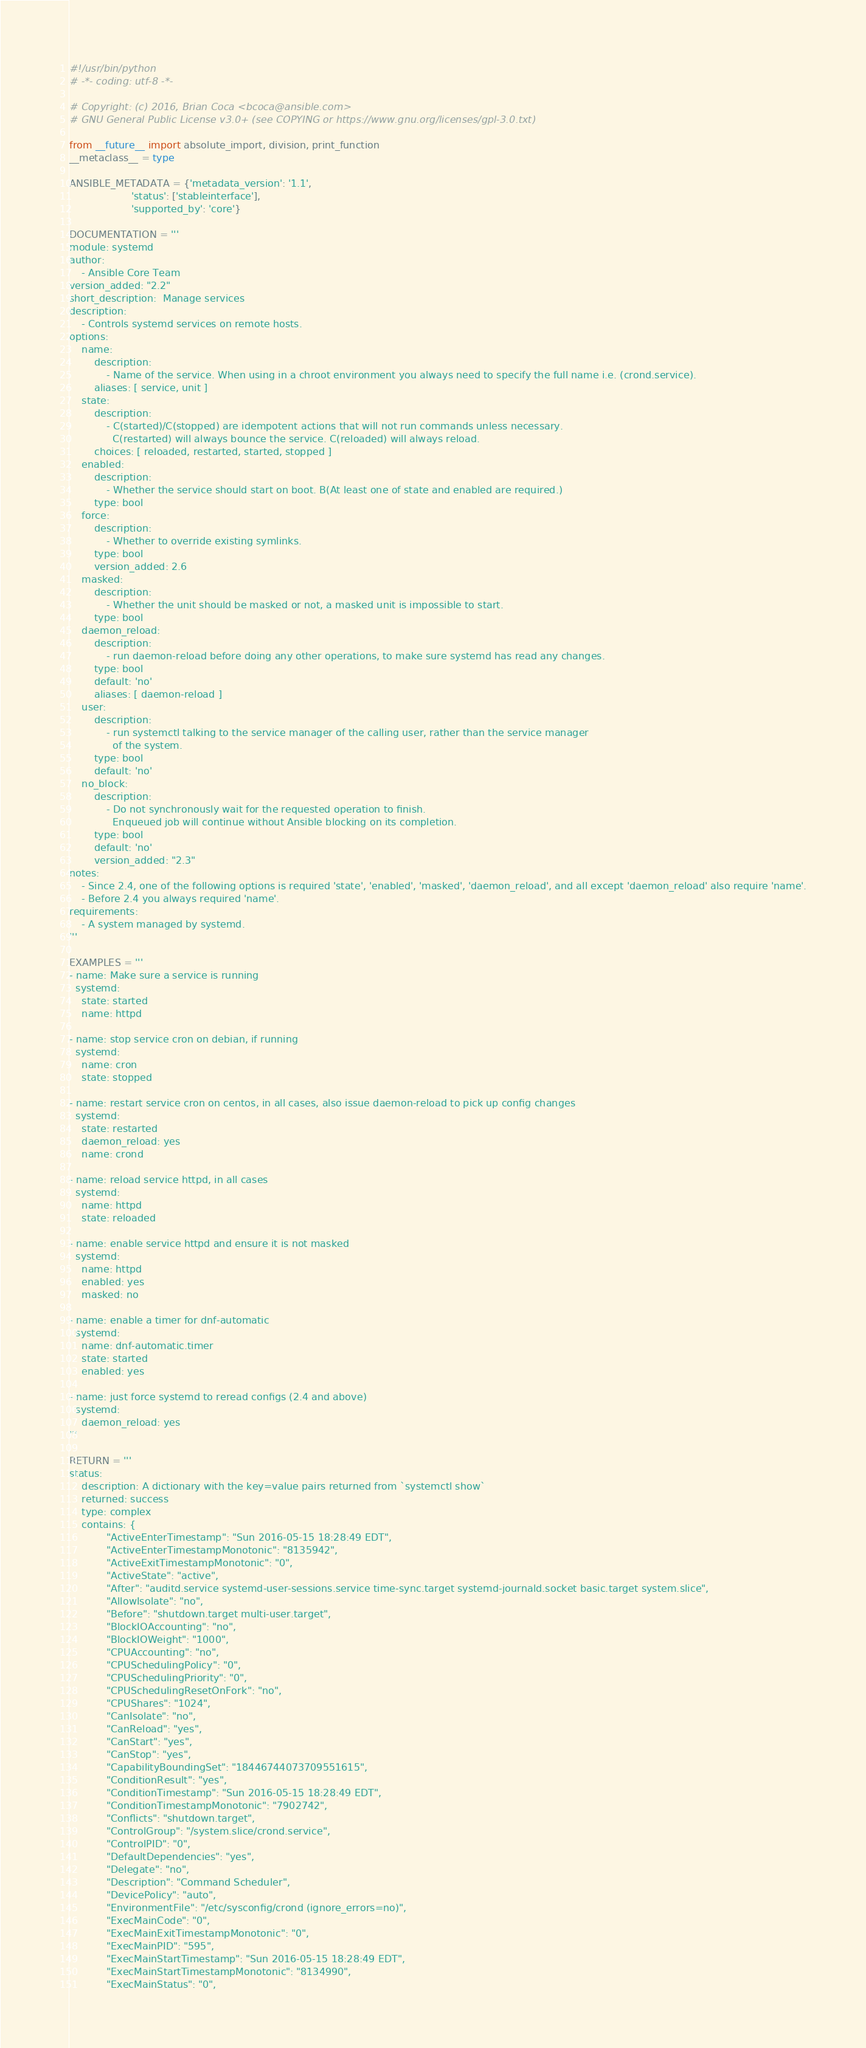Convert code to text. <code><loc_0><loc_0><loc_500><loc_500><_Python_>#!/usr/bin/python
# -*- coding: utf-8 -*-

# Copyright: (c) 2016, Brian Coca <bcoca@ansible.com>
# GNU General Public License v3.0+ (see COPYING or https://www.gnu.org/licenses/gpl-3.0.txt)

from __future__ import absolute_import, division, print_function
__metaclass__ = type

ANSIBLE_METADATA = {'metadata_version': '1.1',
                    'status': ['stableinterface'],
                    'supported_by': 'core'}

DOCUMENTATION = '''
module: systemd
author:
    - Ansible Core Team
version_added: "2.2"
short_description:  Manage services
description:
    - Controls systemd services on remote hosts.
options:
    name:
        description:
            - Name of the service. When using in a chroot environment you always need to specify the full name i.e. (crond.service).
        aliases: [ service, unit ]
    state:
        description:
            - C(started)/C(stopped) are idempotent actions that will not run commands unless necessary.
              C(restarted) will always bounce the service. C(reloaded) will always reload.
        choices: [ reloaded, restarted, started, stopped ]
    enabled:
        description:
            - Whether the service should start on boot. B(At least one of state and enabled are required.)
        type: bool
    force:
        description:
            - Whether to override existing symlinks.
        type: bool
        version_added: 2.6
    masked:
        description:
            - Whether the unit should be masked or not, a masked unit is impossible to start.
        type: bool
    daemon_reload:
        description:
            - run daemon-reload before doing any other operations, to make sure systemd has read any changes.
        type: bool
        default: 'no'
        aliases: [ daemon-reload ]
    user:
        description:
            - run systemctl talking to the service manager of the calling user, rather than the service manager
              of the system.
        type: bool
        default: 'no'
    no_block:
        description:
            - Do not synchronously wait for the requested operation to finish.
              Enqueued job will continue without Ansible blocking on its completion.
        type: bool
        default: 'no'
        version_added: "2.3"
notes:
    - Since 2.4, one of the following options is required 'state', 'enabled', 'masked', 'daemon_reload', and all except 'daemon_reload' also require 'name'.
    - Before 2.4 you always required 'name'.
requirements:
    - A system managed by systemd.
'''

EXAMPLES = '''
- name: Make sure a service is running
  systemd:
    state: started
    name: httpd

- name: stop service cron on debian, if running
  systemd:
    name: cron
    state: stopped

- name: restart service cron on centos, in all cases, also issue daemon-reload to pick up config changes
  systemd:
    state: restarted
    daemon_reload: yes
    name: crond

- name: reload service httpd, in all cases
  systemd:
    name: httpd
    state: reloaded

- name: enable service httpd and ensure it is not masked
  systemd:
    name: httpd
    enabled: yes
    masked: no

- name: enable a timer for dnf-automatic
  systemd:
    name: dnf-automatic.timer
    state: started
    enabled: yes

- name: just force systemd to reread configs (2.4 and above)
  systemd:
    daemon_reload: yes
'''

RETURN = '''
status:
    description: A dictionary with the key=value pairs returned from `systemctl show`
    returned: success
    type: complex
    contains: {
            "ActiveEnterTimestamp": "Sun 2016-05-15 18:28:49 EDT",
            "ActiveEnterTimestampMonotonic": "8135942",
            "ActiveExitTimestampMonotonic": "0",
            "ActiveState": "active",
            "After": "auditd.service systemd-user-sessions.service time-sync.target systemd-journald.socket basic.target system.slice",
            "AllowIsolate": "no",
            "Before": "shutdown.target multi-user.target",
            "BlockIOAccounting": "no",
            "BlockIOWeight": "1000",
            "CPUAccounting": "no",
            "CPUSchedulingPolicy": "0",
            "CPUSchedulingPriority": "0",
            "CPUSchedulingResetOnFork": "no",
            "CPUShares": "1024",
            "CanIsolate": "no",
            "CanReload": "yes",
            "CanStart": "yes",
            "CanStop": "yes",
            "CapabilityBoundingSet": "18446744073709551615",
            "ConditionResult": "yes",
            "ConditionTimestamp": "Sun 2016-05-15 18:28:49 EDT",
            "ConditionTimestampMonotonic": "7902742",
            "Conflicts": "shutdown.target",
            "ControlGroup": "/system.slice/crond.service",
            "ControlPID": "0",
            "DefaultDependencies": "yes",
            "Delegate": "no",
            "Description": "Command Scheduler",
            "DevicePolicy": "auto",
            "EnvironmentFile": "/etc/sysconfig/crond (ignore_errors=no)",
            "ExecMainCode": "0",
            "ExecMainExitTimestampMonotonic": "0",
            "ExecMainPID": "595",
            "ExecMainStartTimestamp": "Sun 2016-05-15 18:28:49 EDT",
            "ExecMainStartTimestampMonotonic": "8134990",
            "ExecMainStatus": "0",</code> 